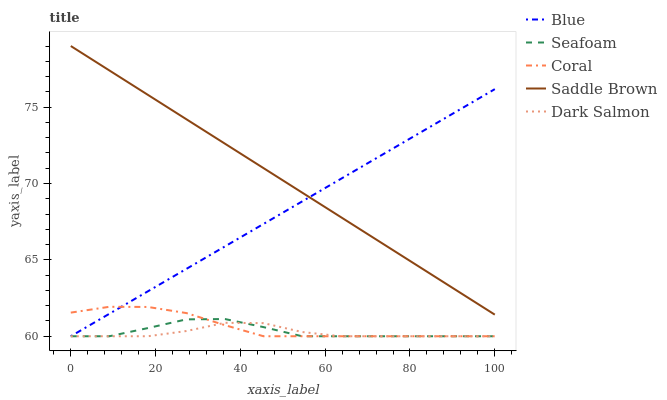Does Dark Salmon have the minimum area under the curve?
Answer yes or no. Yes. Does Saddle Brown have the maximum area under the curve?
Answer yes or no. Yes. Does Coral have the minimum area under the curve?
Answer yes or no. No. Does Coral have the maximum area under the curve?
Answer yes or no. No. Is Blue the smoothest?
Answer yes or no. Yes. Is Seafoam the roughest?
Answer yes or no. Yes. Is Coral the smoothest?
Answer yes or no. No. Is Coral the roughest?
Answer yes or no. No. Does Blue have the lowest value?
Answer yes or no. Yes. Does Saddle Brown have the lowest value?
Answer yes or no. No. Does Saddle Brown have the highest value?
Answer yes or no. Yes. Does Coral have the highest value?
Answer yes or no. No. Is Coral less than Saddle Brown?
Answer yes or no. Yes. Is Saddle Brown greater than Coral?
Answer yes or no. Yes. Does Dark Salmon intersect Blue?
Answer yes or no. Yes. Is Dark Salmon less than Blue?
Answer yes or no. No. Is Dark Salmon greater than Blue?
Answer yes or no. No. Does Coral intersect Saddle Brown?
Answer yes or no. No. 